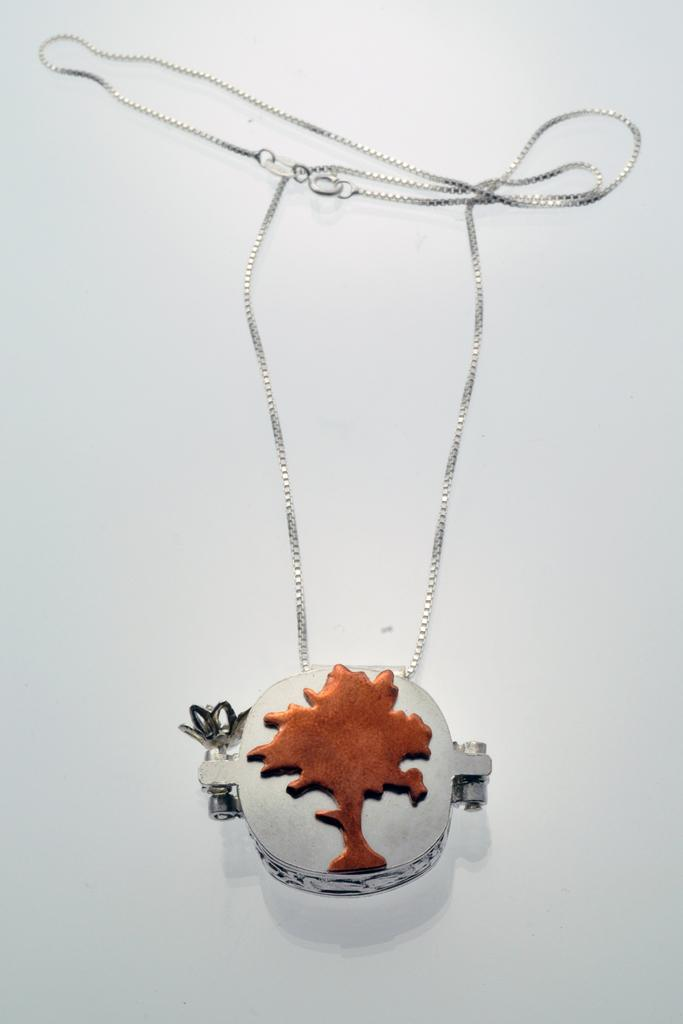What is the main object in the image? There is a chain with a locket in the image. What color is the background of the image? The background of the image is white. What type of business is being conducted in the image? There is no indication of any business being conducted in the image; it only features a chain with a locket against a white background. 